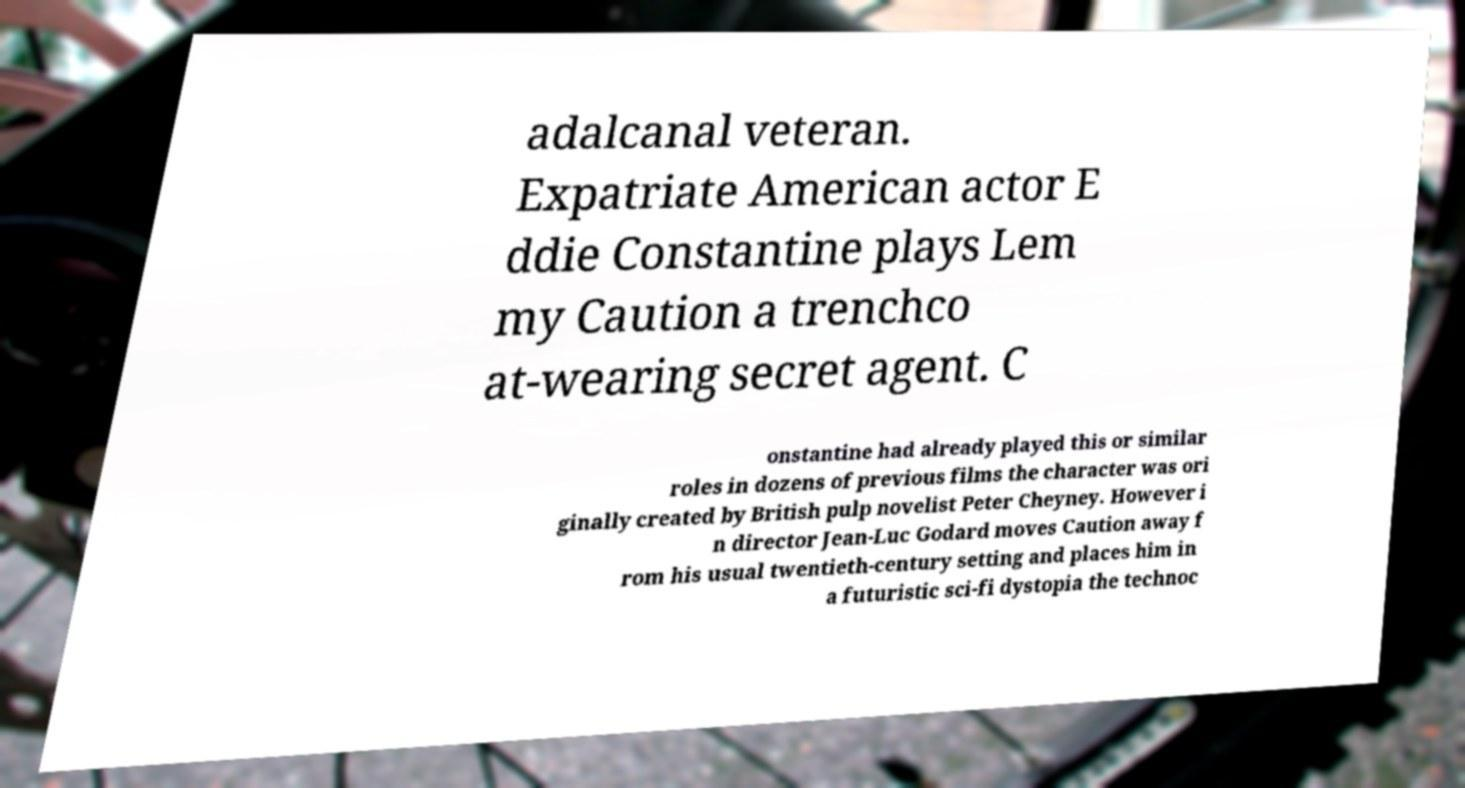Can you accurately transcribe the text from the provided image for me? adalcanal veteran. Expatriate American actor E ddie Constantine plays Lem my Caution a trenchco at-wearing secret agent. C onstantine had already played this or similar roles in dozens of previous films the character was ori ginally created by British pulp novelist Peter Cheyney. However i n director Jean-Luc Godard moves Caution away f rom his usual twentieth-century setting and places him in a futuristic sci-fi dystopia the technoc 